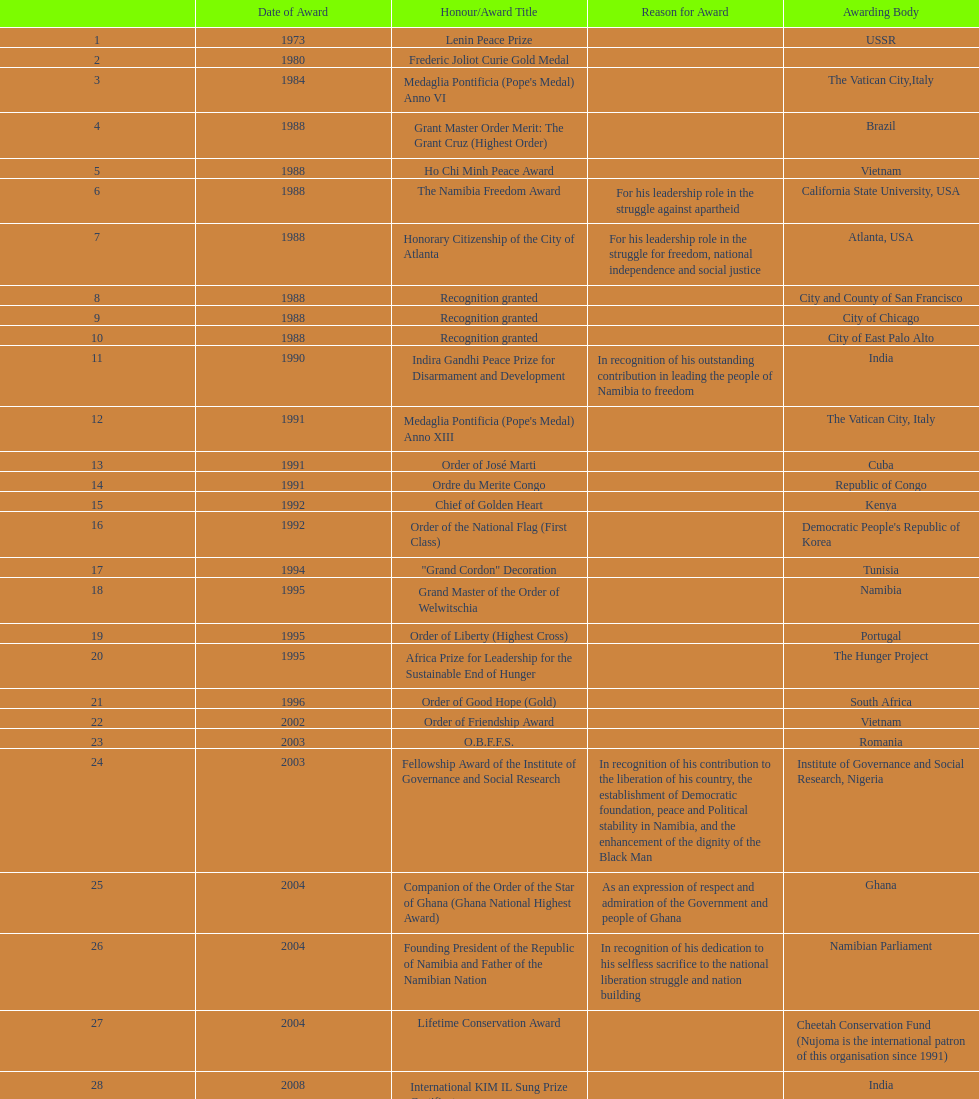Which year was the most honors/award titles given? 1988. 